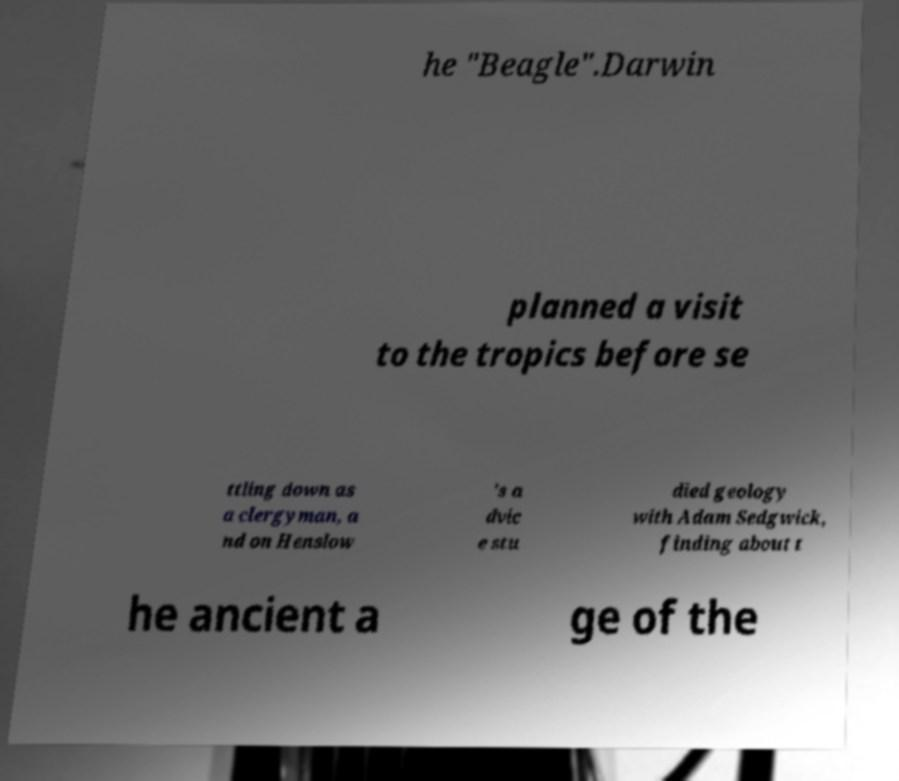Could you assist in decoding the text presented in this image and type it out clearly? he "Beagle".Darwin planned a visit to the tropics before se ttling down as a clergyman, a nd on Henslow 's a dvic e stu died geology with Adam Sedgwick, finding about t he ancient a ge of the 